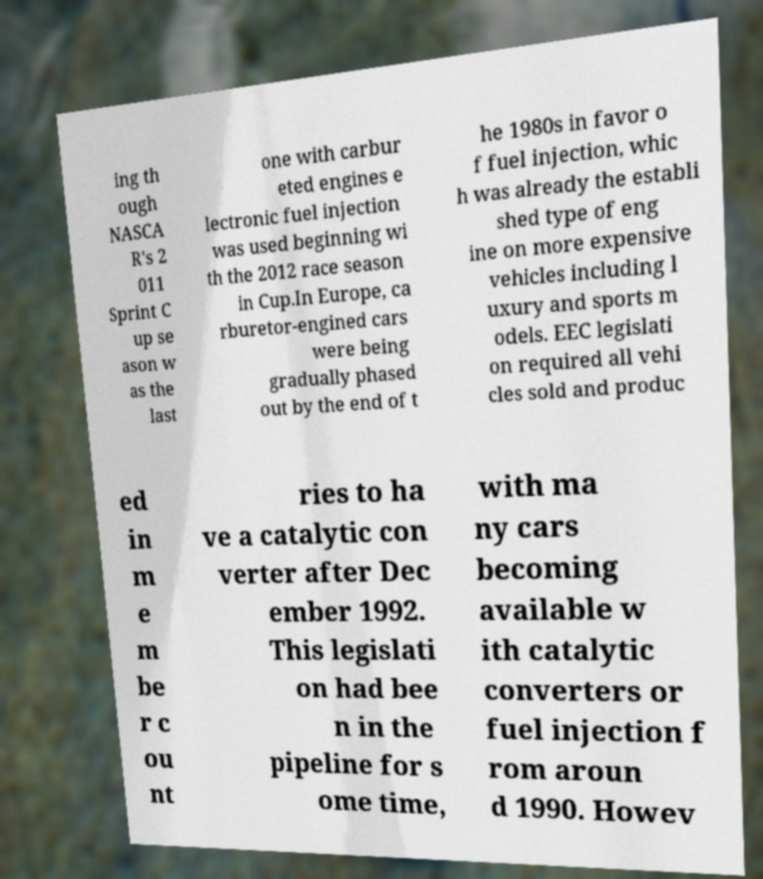For documentation purposes, I need the text within this image transcribed. Could you provide that? ing th ough NASCA R's 2 011 Sprint C up se ason w as the last one with carbur eted engines e lectronic fuel injection was used beginning wi th the 2012 race season in Cup.In Europe, ca rburetor-engined cars were being gradually phased out by the end of t he 1980s in favor o f fuel injection, whic h was already the establi shed type of eng ine on more expensive vehicles including l uxury and sports m odels. EEC legislati on required all vehi cles sold and produc ed in m e m be r c ou nt ries to ha ve a catalytic con verter after Dec ember 1992. This legislati on had bee n in the pipeline for s ome time, with ma ny cars becoming available w ith catalytic converters or fuel injection f rom aroun d 1990. Howev 